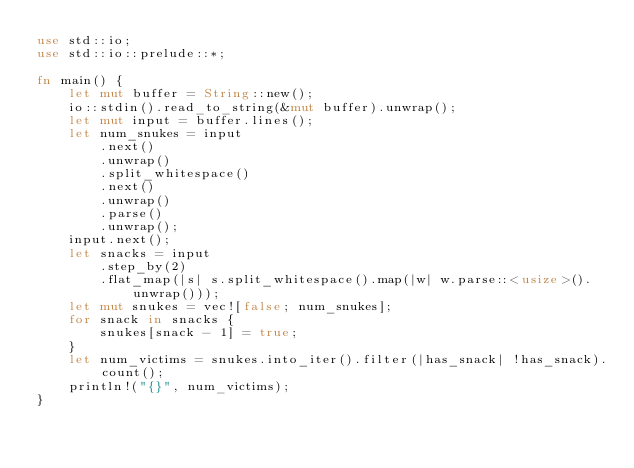Convert code to text. <code><loc_0><loc_0><loc_500><loc_500><_Rust_>use std::io;
use std::io::prelude::*;

fn main() {
    let mut buffer = String::new();
    io::stdin().read_to_string(&mut buffer).unwrap();
    let mut input = buffer.lines();
    let num_snukes = input
        .next()
        .unwrap()
        .split_whitespace()
        .next()
        .unwrap()
        .parse()
        .unwrap();
    input.next();
    let snacks = input
        .step_by(2)
        .flat_map(|s| s.split_whitespace().map(|w| w.parse::<usize>().unwrap()));
    let mut snukes = vec![false; num_snukes];
    for snack in snacks {
        snukes[snack - 1] = true;
    }
    let num_victims = snukes.into_iter().filter(|has_snack| !has_snack).count();
    println!("{}", num_victims);
}
</code> 